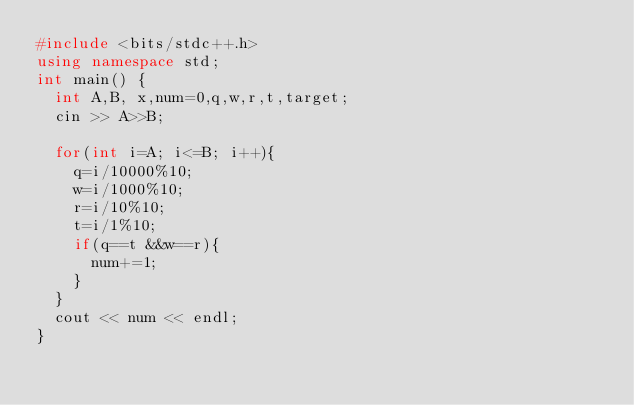Convert code to text. <code><loc_0><loc_0><loc_500><loc_500><_C++_>#include <bits/stdc++.h>
using namespace std;
int main() {
  int A,B, x,num=0,q,w,r,t,target;
  cin >> A>>B;

  for(int i=A; i<=B; i++){
    q=i/10000%10;
    w=i/1000%10;
    r=i/10%10;
    t=i/1%10;
    if(q==t &&w==r){
      num+=1;
    }
  }
  cout << num << endl;
}</code> 